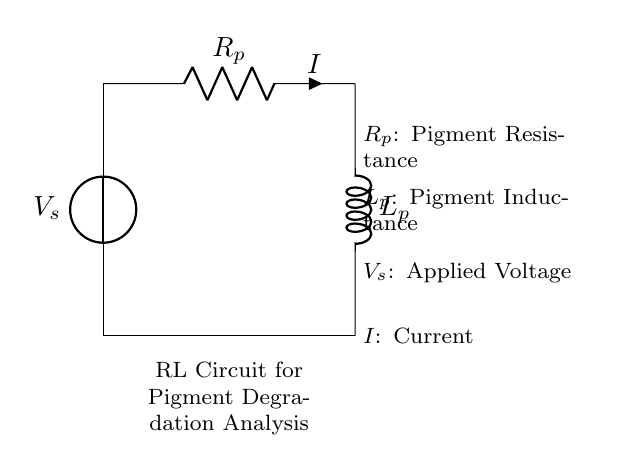What are the two main components in this circuit? The circuit prominently features a resistor and an inductor as its main components. These components are essential for analyzing electrical characteristics, such as the degradation of pigments over time.
Answer: resistor, inductor What is the label for the current in the circuit? The current in the circuit is indicated by the symbol "I," which represents the flow of charge through the components. The label is directly associated with the connection near the resistor.
Answer: I What does the symbol "Vs" represent in this circuit? The symbol "Vs" refers to the applied voltage source in the circuit, denoting the potential difference supplied to drive the current through the resistor and inductor. This is crucial for the analysis of how pigments react over time.
Answer: applied voltage How does the presence of the inductor affect the circuit's response? The inductor introduces reactance, which delays the current change in the circuit. Its inductance causes the current to rise gradually instead of instantly, which is important in studying how painting pigments degrade over time under varying electrical conditions.
Answer: delays current change What is the significance of the resistance labeled R_p? The resistance "R_p" represents the pigment resistance in this analysis, which affects how the current flows through the circuit. Understanding this resistance is crucial for evaluating the degradation of the pigment based on its electrical properties.
Answer: pigment resistance What effect does increasing the inductance L_p have on the circuit behavior? Increasing the inductance L_p increases the time constant of the RL circuit, which results in a slower rate of current increase and a longer decay time. This impacts the analysis of pigment degradation as it alters the response of the circuit significantly over time.
Answer: slower current response How is the voltage "Vs" related to the current "I" in this RL circuit? In this RL circuit, Ohm's Law applies, where the voltage "Vs" across the circuit is proportional to the current "I" multiplied by the total resistance. This relationship helps in understanding how voltage and current influence the degradation process of pigments in the artwork over time.
Answer: proportional relationship 